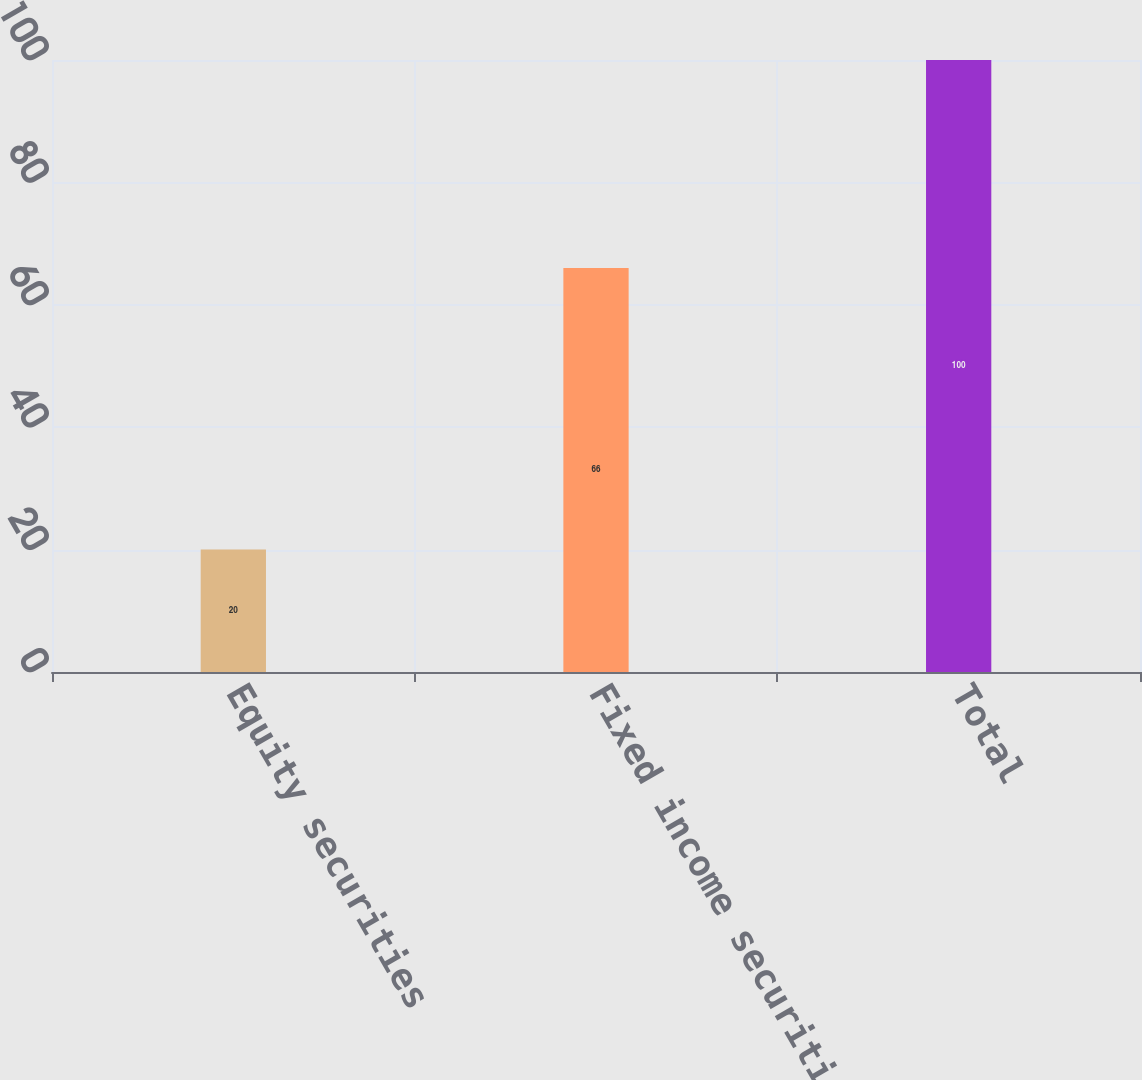Convert chart. <chart><loc_0><loc_0><loc_500><loc_500><bar_chart><fcel>Equity securities<fcel>Fixed income securities<fcel>Total<nl><fcel>20<fcel>66<fcel>100<nl></chart> 